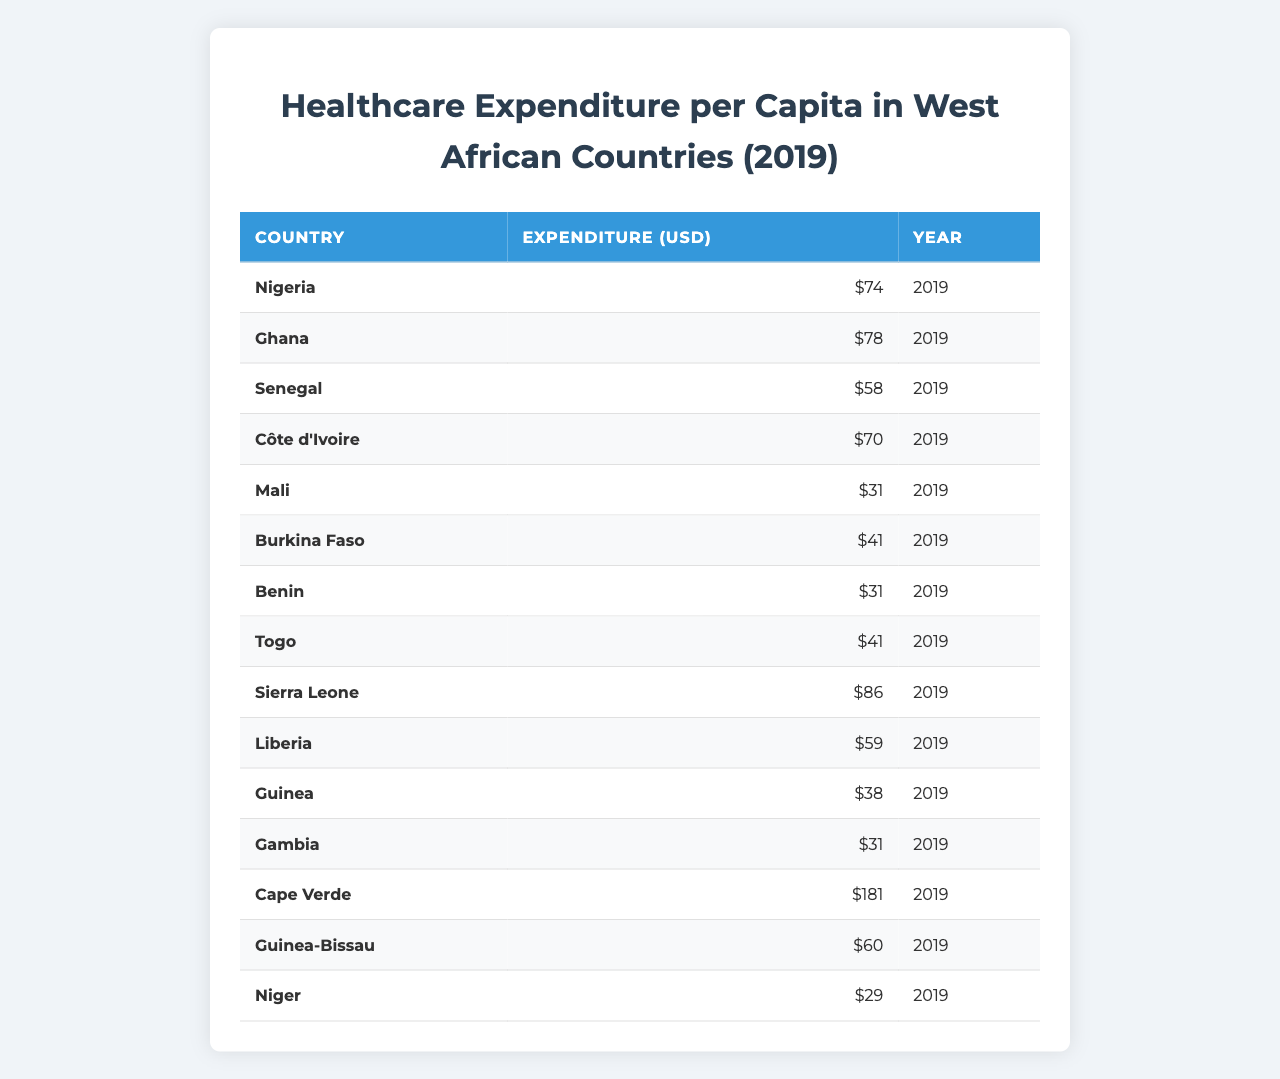What is the healthcare expenditure per capita for Nigeria in 2019? According to the table, Nigeria's healthcare expenditure per capita for the year 2019 is reported as 74 USD.
Answer: 74 USD Which country has the highest healthcare expenditure per capita? The table shows that Cape Verde has the highest healthcare expenditure per capita at 181 USD in 2019.
Answer: Cape Verde How much did Sierra Leone spend on healthcare per capita in 2019 compared to Niger? Sierra Leone's healthcare expenditure is 86 USD, while Niger's is 29 USD. The difference is 86 - 29 = 57 USD, indicating Sierra Leone spent 57 USD more per capita than Niger.
Answer: 57 USD What is the average healthcare expenditure per capita of the countries listed in the table? To find the average, we sum all the expenditures: (74 + 78 + 58 + 70 + 31 + 41 + 31 + 41 + 86 + 59 + 38 + 31 + 181 + 60 + 29) =  782 USD. There are 15 countries, so the average is 782 / 15 ≈ 52.13 USD.
Answer: Approximately 52.13 USD Is the healthcare expenditure per capita in Ghana greater than 70 USD? The table shows Ghana's healthcare expenditure per capita is 78 USD, which is greater than 70 USD.
Answer: Yes Which two countries have the lowest healthcare expenditure per capita? The countries with the lowest expenditures are Niger and Mali, both at 29 USD and 31 USD, respectively.
Answer: Niger and Mali What is the total healthcare expenditure per capita for all the countries combined? Summing all the expenditures gives us: 782 USD. This is the total expenditure per capita across all listed countries.
Answer: 782 USD Does Liberia have a healthcare expenditure per capita below the average of all countries? The average calculated previously is approximately 52.13 USD. Liberia's expenditure is 59 USD, which is above the average.
Answer: No How much greater is Sierra Leone's healthcare expenditure than that of Guinea-Bissau? Sierra Leone spends 86 USD while Guinea-Bissau spends 60 USD. The difference is 86 - 60 = 26 USD.
Answer: 26 USD Which country has a healthcare expenditure per capita that is closest to the budget of 40 USD? Burkina Faso and Togo each have expenditures of 41 USD, which is the closest to 40 USD.
Answer: Burkina Faso and Togo 